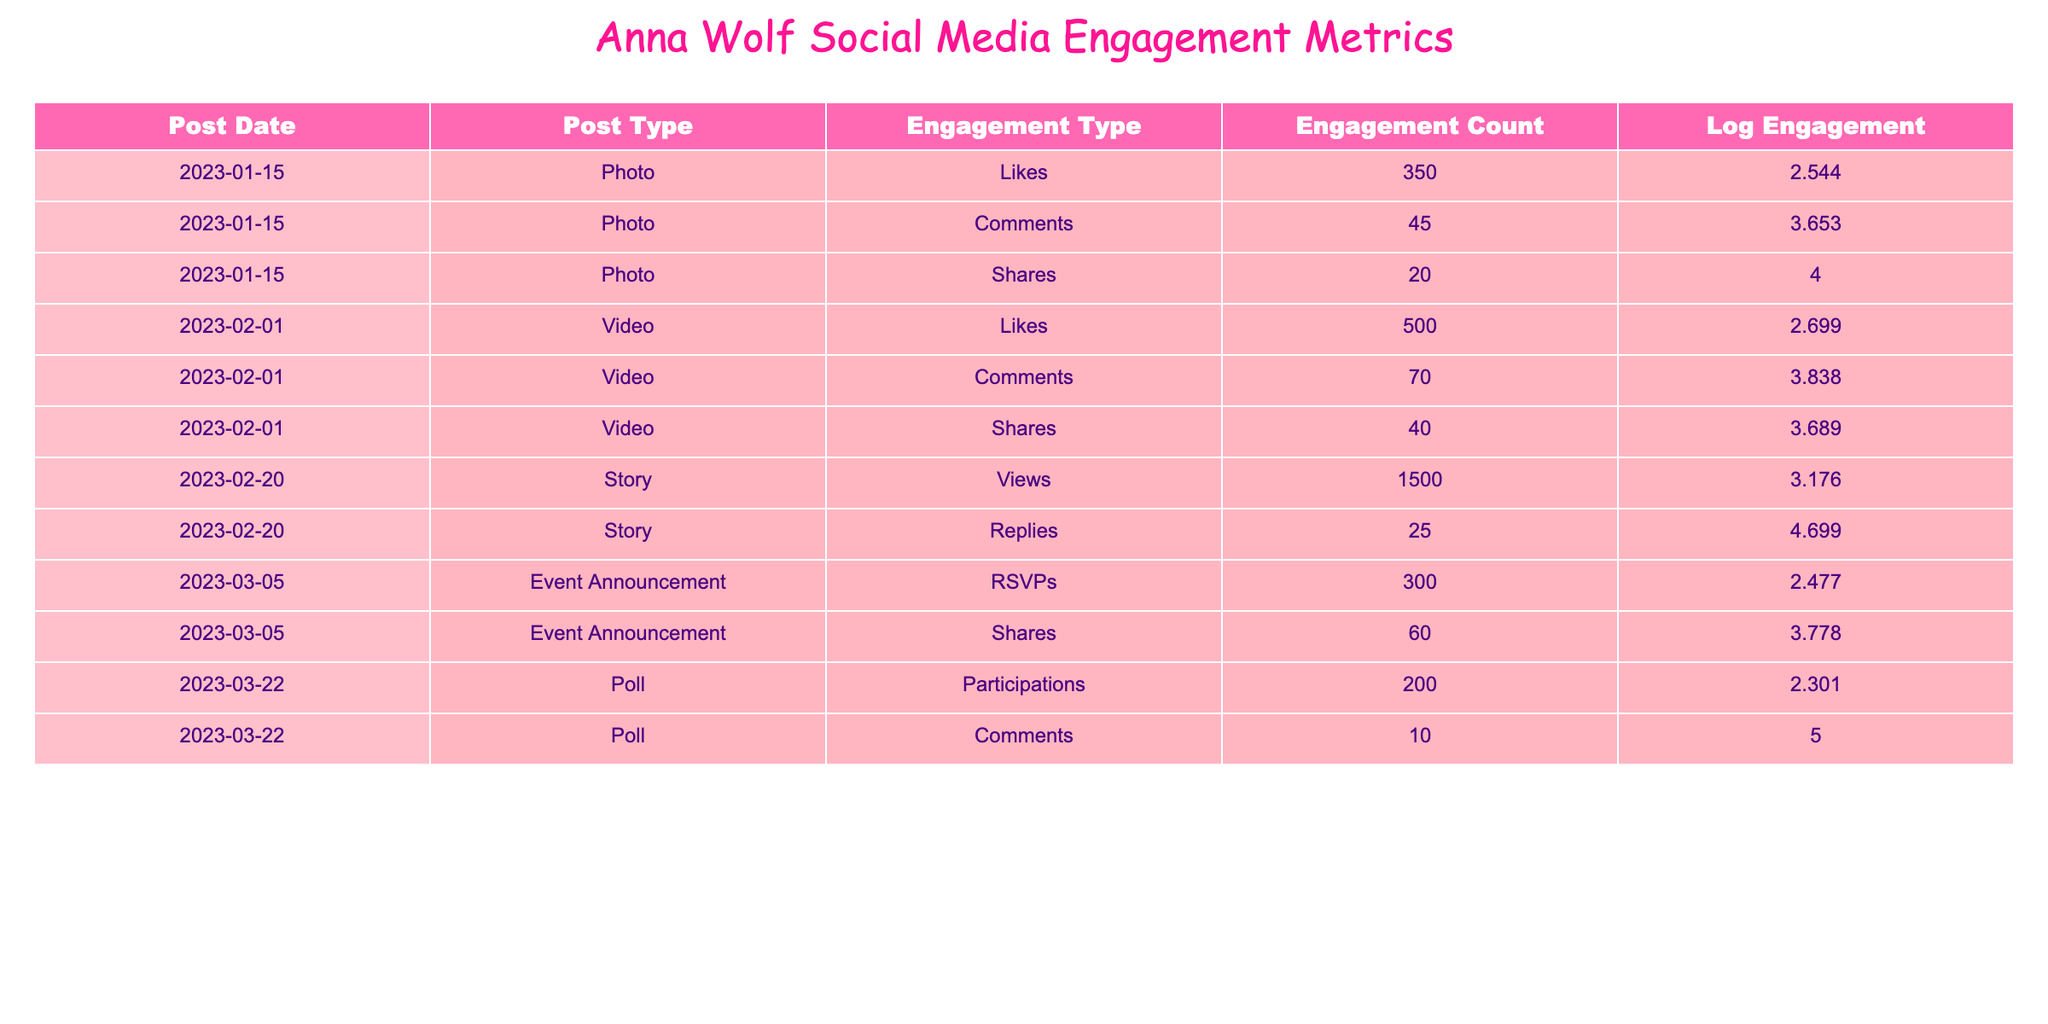What is the total engagement count for the Photo post on January 15, 2023? The engagement count for the Photo post on January 15 is taken from three engagement types: Likes (350), Comments (45), and Shares (20). Therefore, I add these values: 350 + 45 + 20 = 415.
Answer: 415 What is the highest engagement type for the Video post on February 1, 2023? The engagement types for the Video post on February 1 are Likes (500), Comments (70), and Shares (40). Among these, Likes has the highest count at 500.
Answer: Likes Is there a Poll post that received more than 10 comments? There is a Poll post on March 22, 2023, with Comments (10). Since 10 is not more than 10, the statement is false.
Answer: No What was the total engagement count for all Story posts combined? There is one Story post recorded on February 20, with Views (1500) and Replies (25). I combine these values to get the total engagement: 1500 + 25 = 1525.
Answer: 1525 Which post type had the largest engagement count across all recorded posts? To determine the post type with the largest engagement, I need to review all engagement counts across post types. The highest individual engagement is for the Video post Likes (500), thus marking Videos as the post type with the highest engagement count.
Answer: Video 